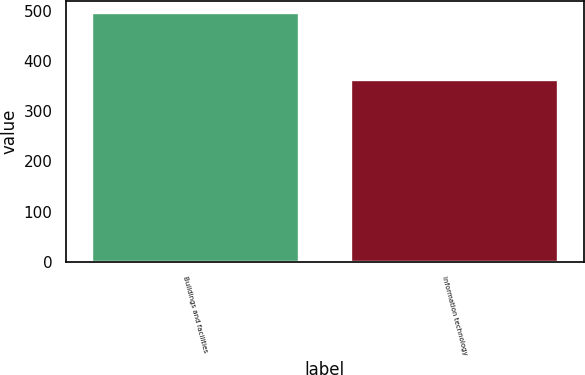Convert chart to OTSL. <chart><loc_0><loc_0><loc_500><loc_500><bar_chart><fcel>Buildings and facilities<fcel>Information technology<nl><fcel>495<fcel>362<nl></chart> 